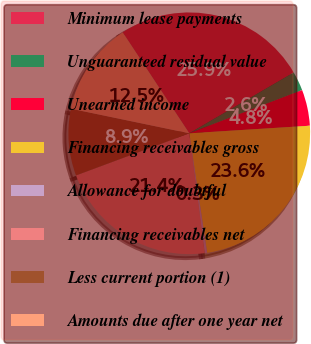Convert chart. <chart><loc_0><loc_0><loc_500><loc_500><pie_chart><fcel>Minimum lease payments<fcel>Unguaranteed residual value<fcel>Unearned income<fcel>Financing receivables gross<fcel>Allowance for doubtful<fcel>Financing receivables net<fcel>Less current portion (1)<fcel>Amounts due after one year net<nl><fcel>25.89%<fcel>2.57%<fcel>4.82%<fcel>23.64%<fcel>0.32%<fcel>21.38%<fcel>8.93%<fcel>12.46%<nl></chart> 